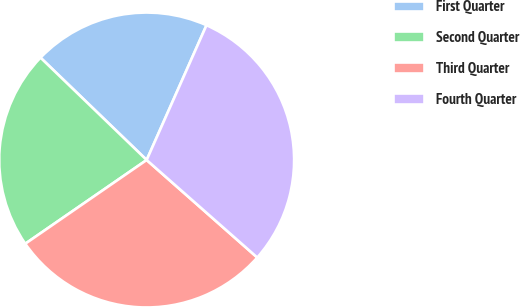Convert chart to OTSL. <chart><loc_0><loc_0><loc_500><loc_500><pie_chart><fcel>First Quarter<fcel>Second Quarter<fcel>Third Quarter<fcel>Fourth Quarter<nl><fcel>19.44%<fcel>21.82%<fcel>28.89%<fcel>29.85%<nl></chart> 